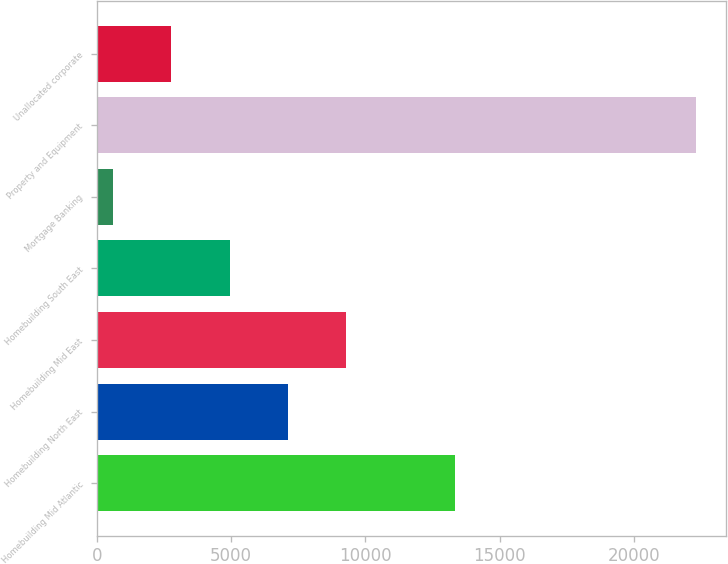<chart> <loc_0><loc_0><loc_500><loc_500><bar_chart><fcel>Homebuilding Mid Atlantic<fcel>Homebuilding North East<fcel>Homebuilding Mid East<fcel>Homebuilding South East<fcel>Mortgage Banking<fcel>Property and Equipment<fcel>Unallocated corporate<nl><fcel>13355<fcel>7120.2<fcel>9289.6<fcel>4950.8<fcel>612<fcel>22306<fcel>2781.4<nl></chart> 